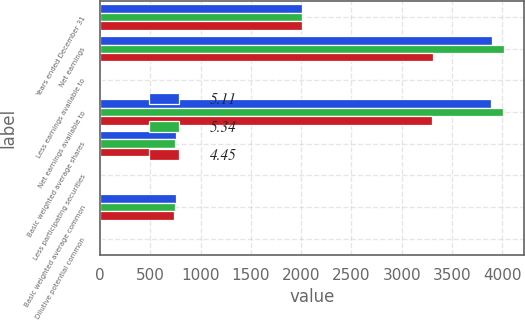Convert chart. <chart><loc_0><loc_0><loc_500><loc_500><stacked_bar_chart><ecel><fcel>Years ended December 31<fcel>Net earnings<fcel>Less earnings available to<fcel>Net earnings available to<fcel>Basic weighted average shares<fcel>Less participating securities<fcel>Basic weighted average common<fcel>Dilutive potential common<nl><fcel>5.11<fcel>2012<fcel>3900<fcel>8<fcel>3892<fcel>758<fcel>2.3<fcel>755.7<fcel>5.8<nl><fcel>5.34<fcel>2011<fcel>4018<fcel>9<fcel>4009<fcel>746.6<fcel>2.5<fcel>744.1<fcel>6.5<nl><fcel>4.45<fcel>2010<fcel>3307<fcel>9<fcel>3298<fcel>738.1<fcel>3.1<fcel>735<fcel>6.2<nl></chart> 